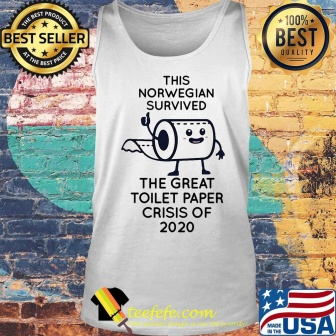Imagine the tank top is part of an alien artifact collection. How would an alien interpret it? An alien might interpret the tank top as a relic indicative of human resilience and humor in the face of scarcity. They could perceive the anthropomorphized toilet paper roll as a representation of how humans assign emotions and characters to inanimate objects, perhaps as a coping mechanism during difficult times. The text could be seen as a historical record, documenting a crisis period in human history, highlighting the species' ability to make light of challenging situations. The 'best seller' and '100% best quality' badges, along with the American flag, might be interpreted as symbols of consumer culture and national pride, indicating the value society places on humor, nostalgia, and quality. 